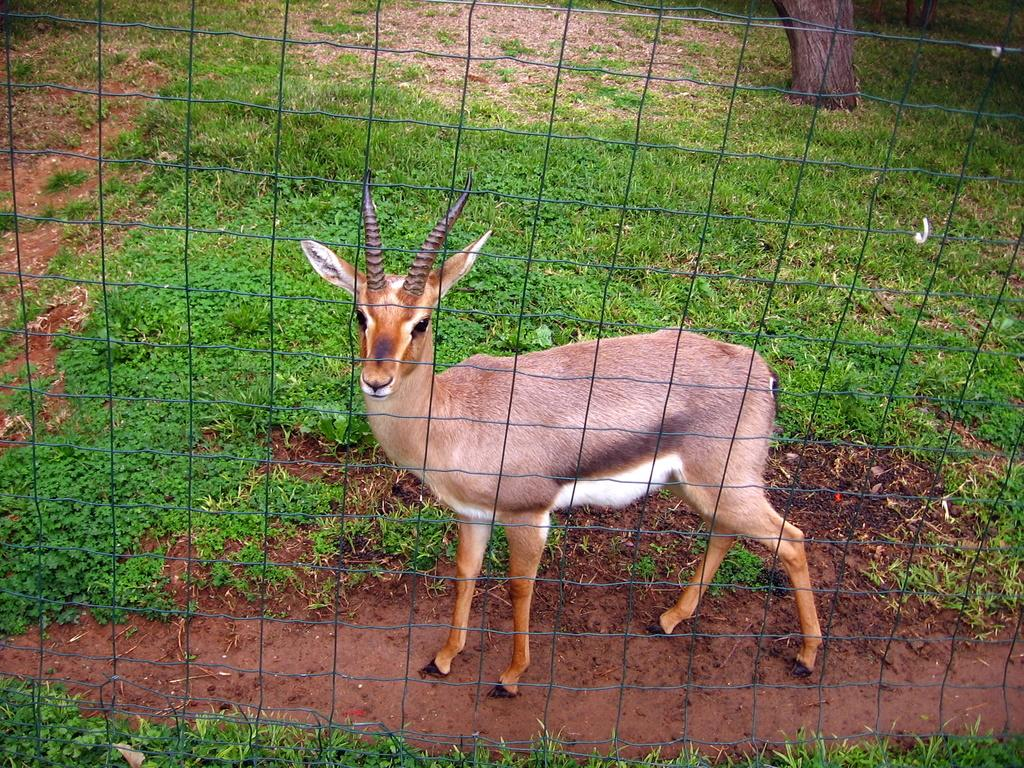What animal is in the center of the image? There is a deer in the center of the image. What type of vegetation is visible in the background of the image? There is grass in the background of the image. Are there any other natural elements in the background? Yes, there is a tree and the ground visible in the background of the image. What type of fencing is used to keep the sheep from wandering off in the image? There is no mention of sheep or fencing for sheep in the image? What type of wool can be seen on the deer in the image? There is no wool present on the deer in the image. The deer is a wild animal and does not have wool. 